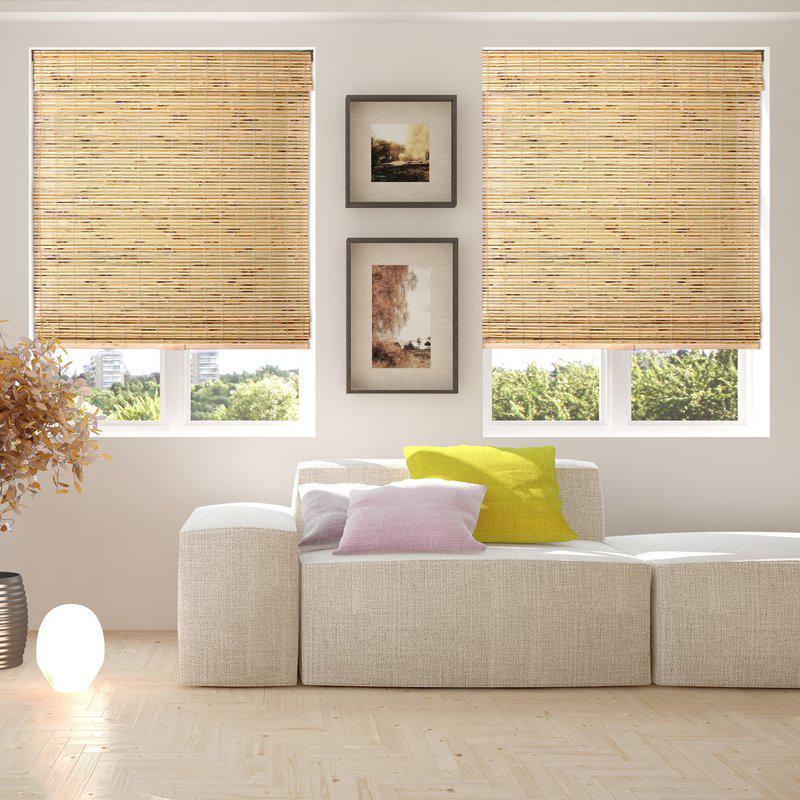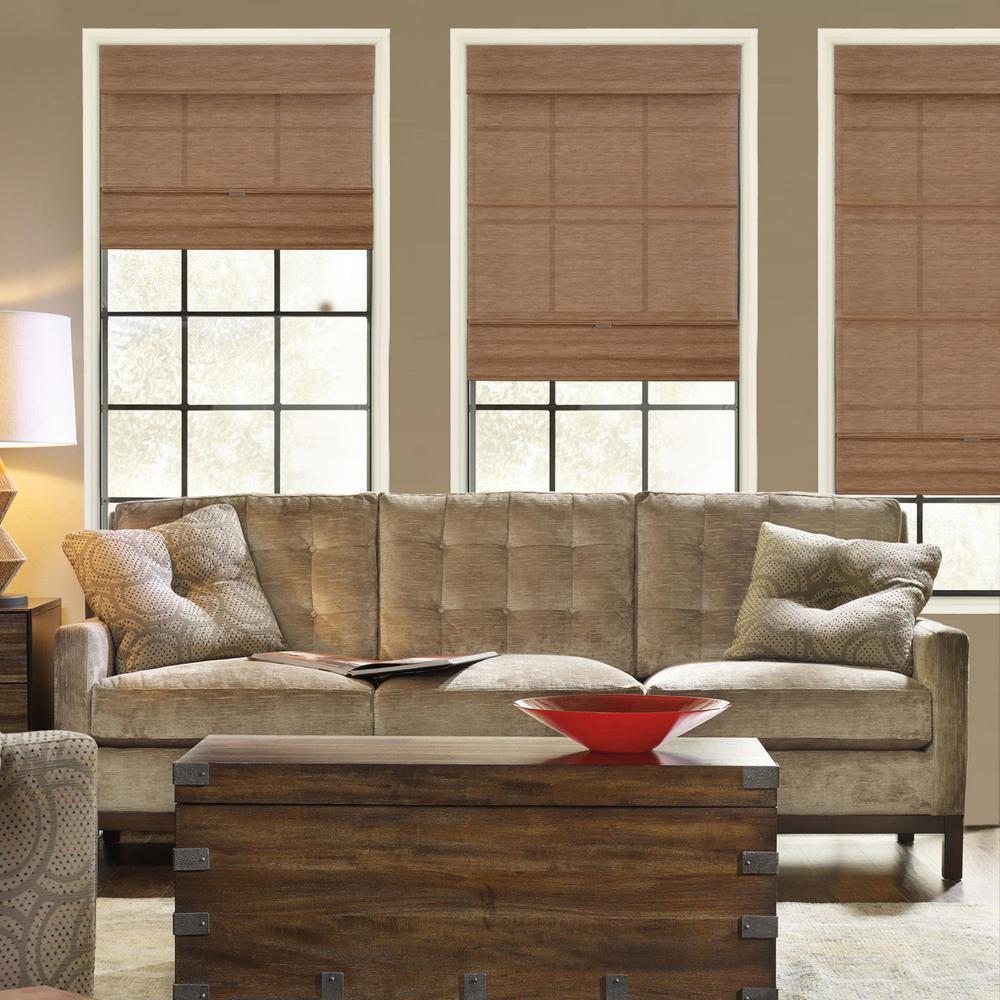The first image is the image on the left, the second image is the image on the right. Analyze the images presented: Is the assertion "All the window shades are partially up." valid? Answer yes or no. Yes. 